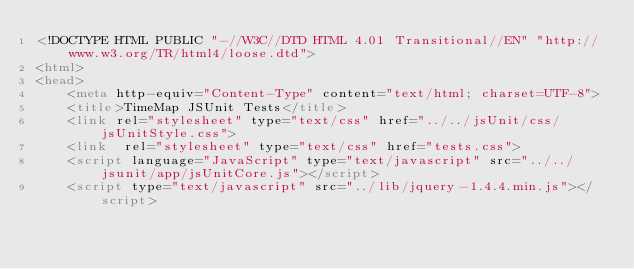<code> <loc_0><loc_0><loc_500><loc_500><_HTML_><!DOCTYPE HTML PUBLIC "-//W3C//DTD HTML 4.01 Transitional//EN" "http://www.w3.org/TR/html4/loose.dtd">
<html>
<head>
    <meta http-equiv="Content-Type" content="text/html; charset=UTF-8">
    <title>TimeMap JSUnit Tests</title>
    <link rel="stylesheet" type="text/css" href="../../jsUnit/css/jsUnitStyle.css">
    <link  rel="stylesheet" type="text/css" href="tests.css">
    <script language="JavaScript" type="text/javascript" src="../../jsunit/app/jsUnitCore.js"></script>
    <script type="text/javascript" src="../lib/jquery-1.4.4.min.js"></script></code> 